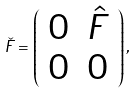<formula> <loc_0><loc_0><loc_500><loc_500>\check { F } = \left ( \begin{array} { c c } 0 & \hat { F } \\ 0 & 0 \end{array} \right ) ,</formula> 